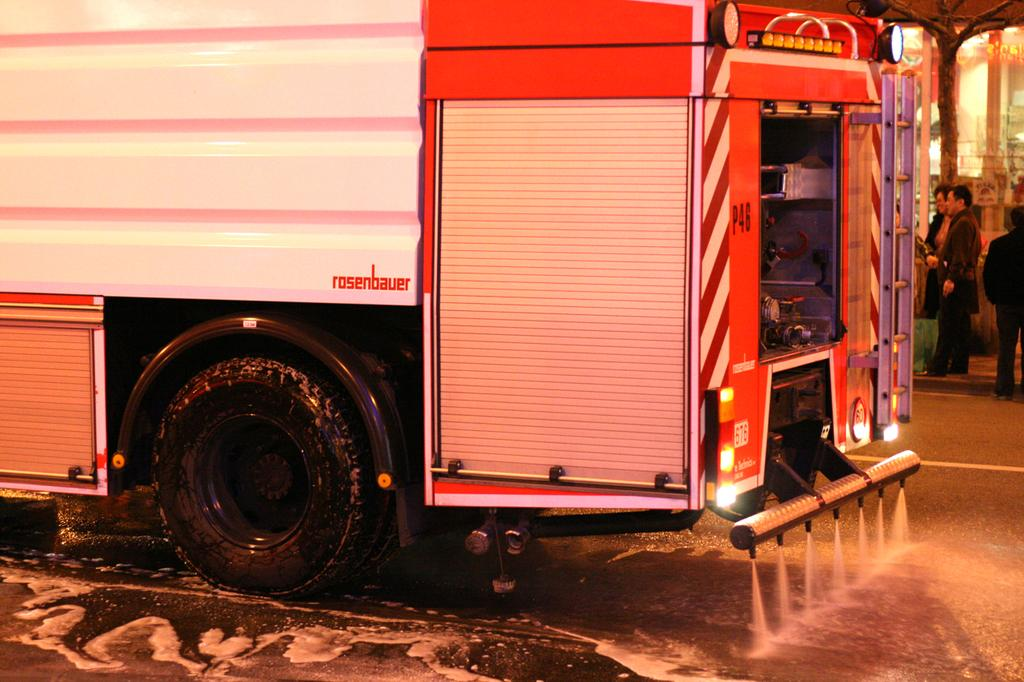What can be seen on the road in the image? There is a vehicle visible on the road in the image. Where are the persons located in the image? The persons are visible on the right side of the image. What is the status of the vehicle's door in the image? The door of the vehicle is open. What is causing the vehicle's throat to hurt in the image? There is no indication of a vehicle's throat in the image, as vehicles do not have throats. 